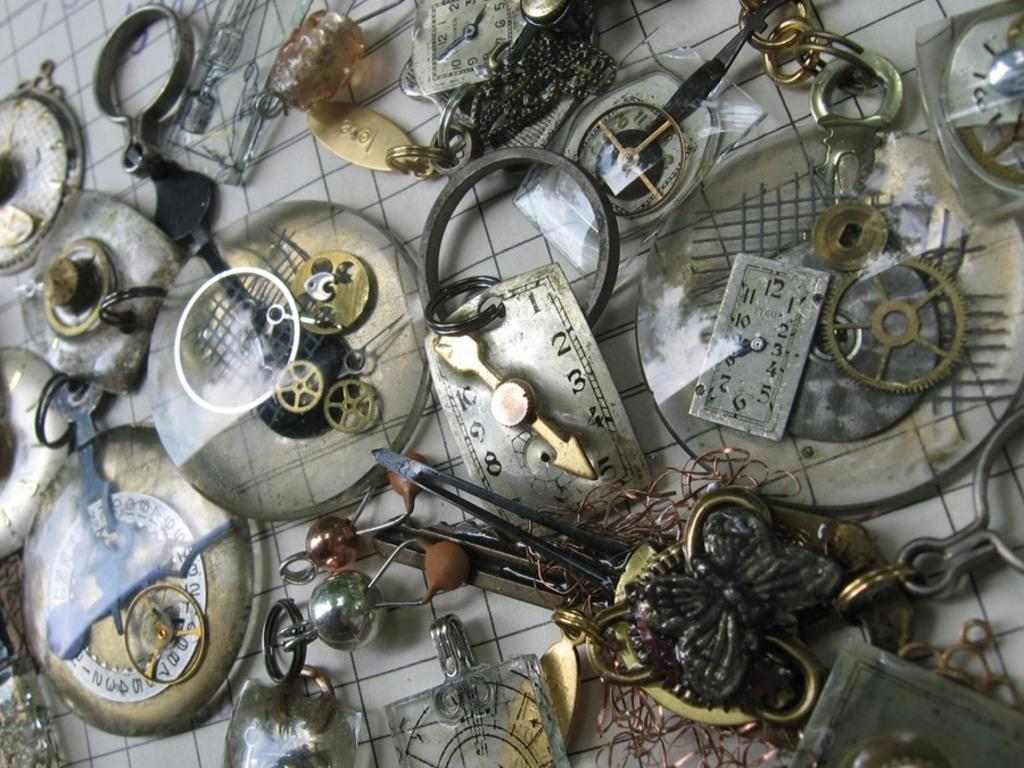What can be seen on the surface in the image? There is equipment on a surface in the image. How many rings are visible on the cactus in the image? There is no cactus or rings present in the image; it only features equipment on a surface. 